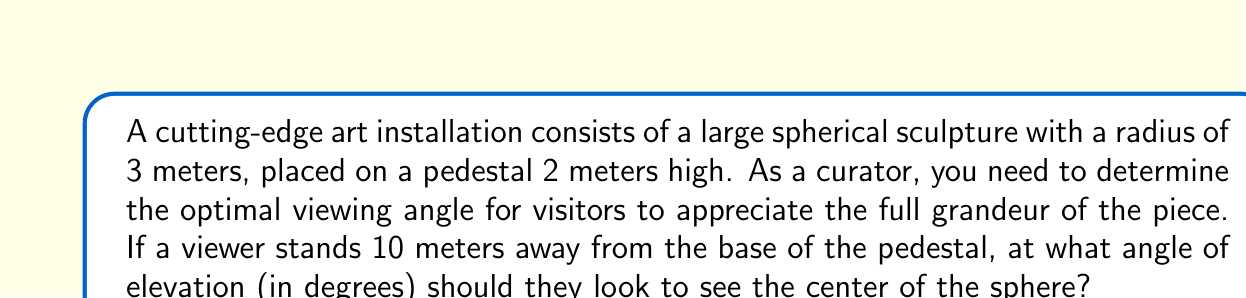Can you solve this math problem? Let's approach this step-by-step:

1) First, let's visualize the problem:

[asy]
import geometry;

unitsize(0.5cm);

pair O = (0,0);
pair A = (10,0);
pair B = (10,2);
pair C = (10,5);

draw(O--A--C--O);
draw(A--B);

draw(Circle(C,3));

label("O", O, SW);
label("A", A, S);
label("B", B, E);
label("C", C, E);

label("10m", (5,0), S);
label("2m", (10,1), E);
label("3m", (10,3.5), E);

draw(O--C,dashed);
draw(anglemark(A,O,C));

label("$\theta$", (1,1), NW);
[/asy]

2) In this diagram:
   - O is the viewer's position
   - A is the base of the pedestal
   - B is the top of the pedestal
   - C is the center of the spherical sculpture

3) We need to find the angle $\theta$ at O.

4) We can solve this using trigonometry. We have a right triangle OAC.

5) In this triangle:
   - The adjacent side OA is 10 meters
   - The opposite side AC is the height of the pedestal (2m) plus the radius of the sphere (3m), so 5 meters in total

6) We can use the tangent function:

   $$\tan(\theta) = \frac{\text{opposite}}{\text{adjacent}} = \frac{5}{10} = 0.5$$

7) To find $\theta$, we take the inverse tangent (arctan or $\tan^{-1}$):

   $$\theta = \tan^{-1}(0.5)$$

8) Using a calculator or computer, we can evaluate this:

   $$\theta \approx 26.57^\circ$$

Thus, the optimal viewing angle is approximately 26.57 degrees.
Answer: The optimal viewing angle is approximately 26.57°. 